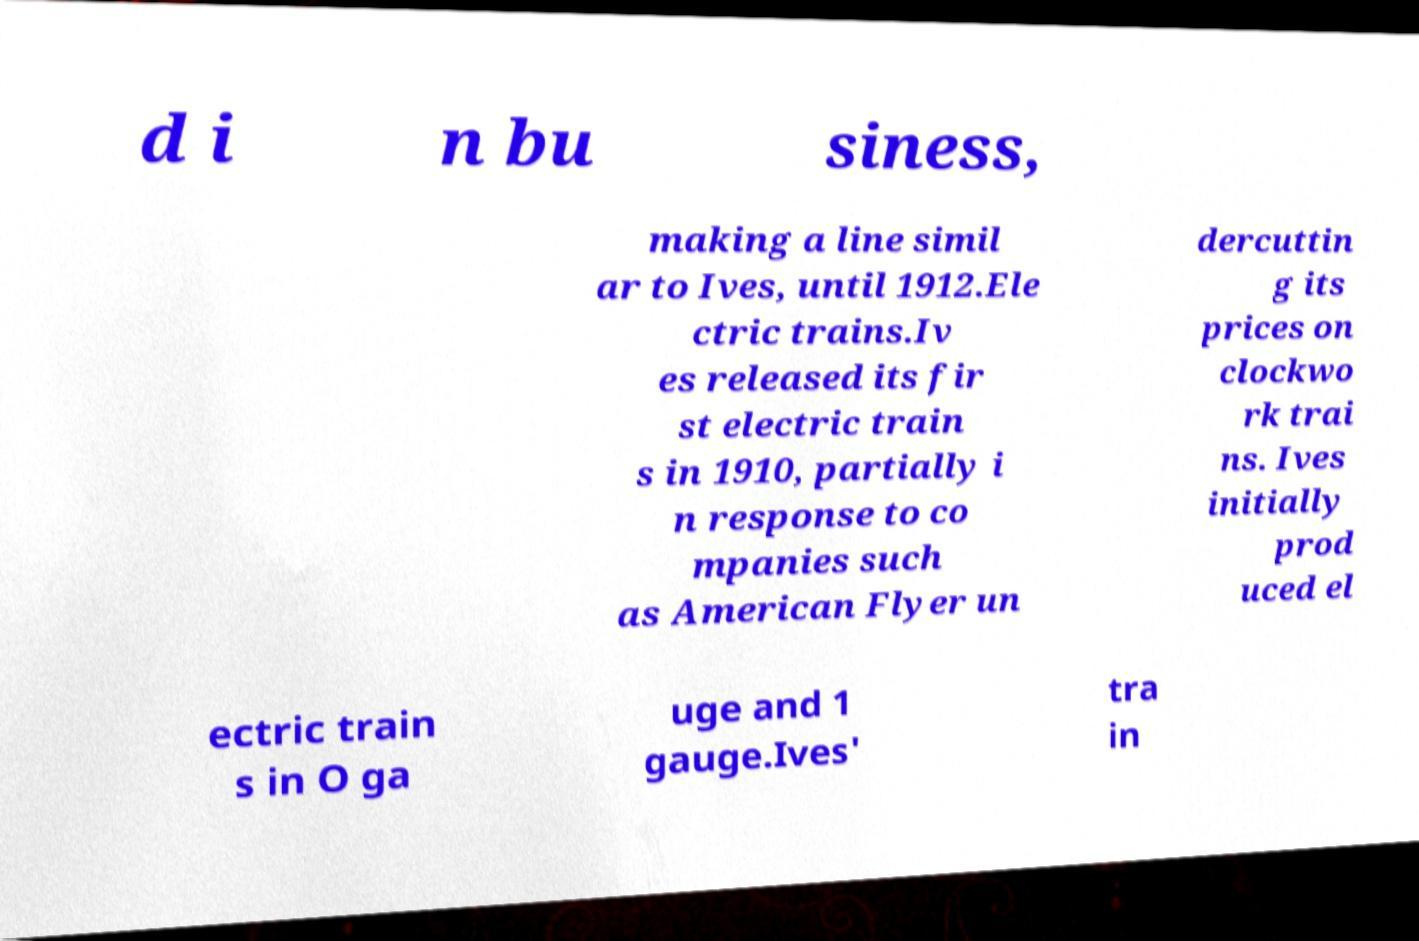Please identify and transcribe the text found in this image. d i n bu siness, making a line simil ar to Ives, until 1912.Ele ctric trains.Iv es released its fir st electric train s in 1910, partially i n response to co mpanies such as American Flyer un dercuttin g its prices on clockwo rk trai ns. Ives initially prod uced el ectric train s in O ga uge and 1 gauge.Ives' tra in 